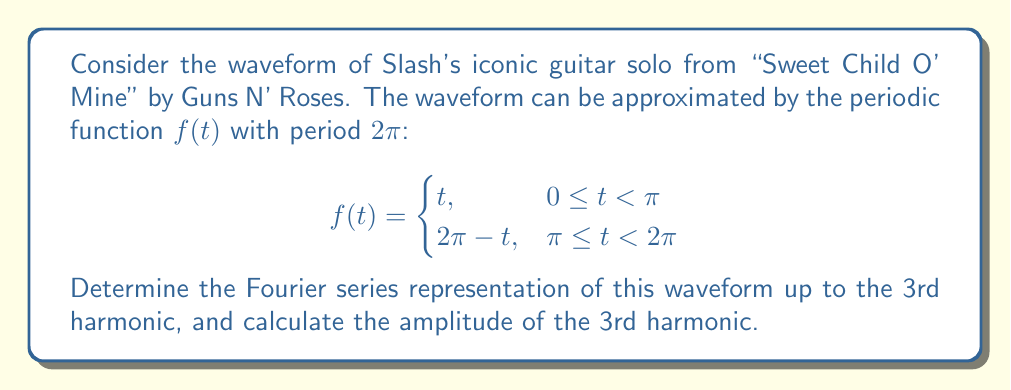Help me with this question. To find the Fourier series representation, we need to calculate the Fourier coefficients $a_0$, $a_n$, and $b_n$. The Fourier series is given by:

$$f(t) = \frac{a_0}{2} + \sum_{n=1}^{\infty} (a_n \cos(nt) + b_n \sin(nt))$$

1) First, calculate $a_0$:
   $$a_0 = \frac{1}{\pi} \int_0^{2\pi} f(t) dt = \frac{1}{\pi} \left(\int_0^{\pi} t dt + \int_{\pi}^{2\pi} (2\pi - t) dt\right) = 2\pi$$

2) Calculate $a_n$:
   $$a_n = \frac{1}{\pi} \int_0^{2\pi} f(t) \cos(nt) dt = 0 \text{ for all } n \geq 1$$

3) Calculate $b_n$:
   $$b_n = \frac{1}{\pi} \int_0^{2\pi} f(t) \sin(nt) dt = \frac{1}{\pi} \left(\int_0^{\pi} t \sin(nt) dt + \int_{\pi}^{2\pi} (2\pi - t) \sin(nt) dt\right)$$
   
   After integration and simplification:
   $$b_n = \frac{4}{n^2} \text{ for odd } n, \text{ and } 0 \text{ for even } n$$

4) The Fourier series up to the 3rd harmonic is:
   $$f(t) \approx \pi + \frac{4}{\pi} \sin(t) + \frac{4}{9\pi} \sin(3t)$$

5) The amplitude of the 3rd harmonic is the coefficient of $\sin(3t)$, which is $\frac{4}{9\pi}$.
Answer: The Fourier series representation up to the 3rd harmonic is:
$$f(t) \approx \pi + \frac{4}{\pi} \sin(t) + \frac{4}{9\pi} \sin(3t)$$

The amplitude of the 3rd harmonic is $\frac{4}{9\pi}$. 